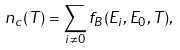<formula> <loc_0><loc_0><loc_500><loc_500>n _ { c } ( T ) = \sum _ { i \neq 0 } f _ { B } ( E _ { i } , E _ { 0 } , T ) ,</formula> 